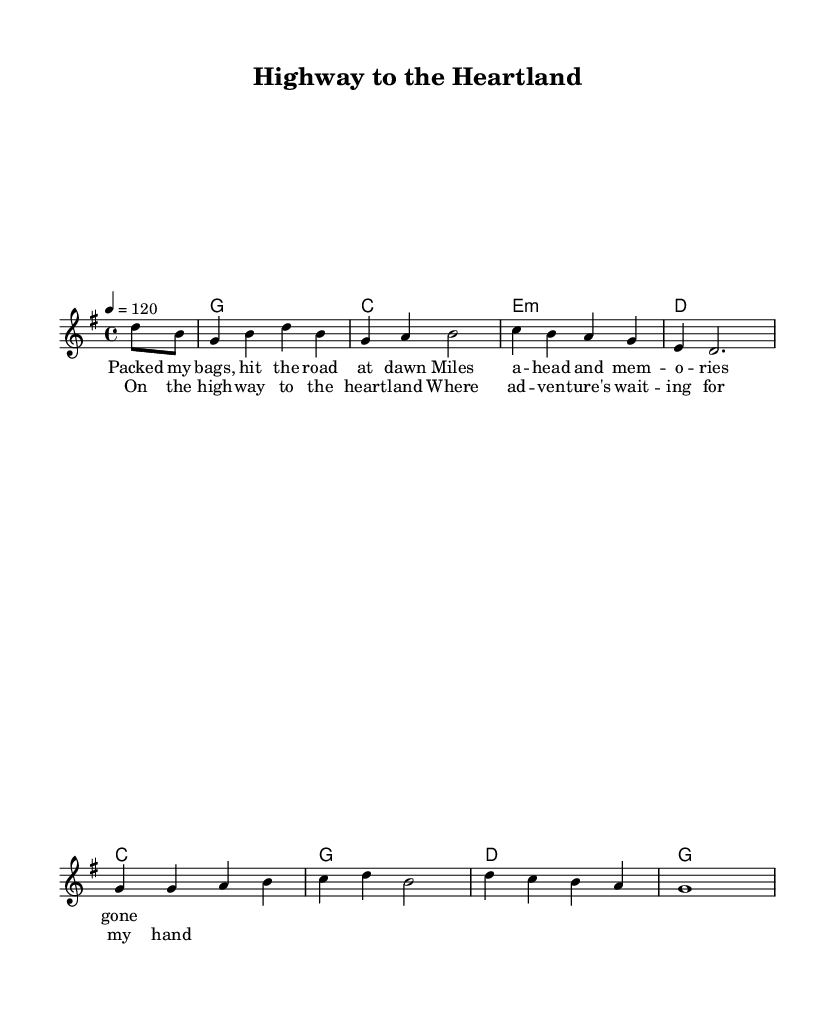What is the key signature of this music? The key signature is G major, which has one sharp (F#). This can be determined by identifying the key signature notation in the sheet music.
Answer: G major What is the time signature of this music? The time signature is 4/4, which means there are four beats in each measure and the quarter note gets one beat. This is indicated at the beginning of the score right after the key signature.
Answer: 4/4 What is the tempo marking for this piece? The tempo marking is 120 beats per minute, which is indicated with "4 = 120" in the tempo instructions. This designation tells the performer how fast to play the piece.
Answer: 120 beats per minute What is the main theme of the lyrics in this piece? The main theme of the lyrics revolves around travel and adventure, as reflected in lines like "Packed my bags, hit the road at dawn". The overall message conveys the excitement of heading towards new experiences.
Answer: Travel and adventure How many measures are there in the melody? The melody consists of eight measures. This can be counted by examining the structure of the melody line provided in the sheet music, where each group of notes is grouped into measures.
Answer: Eight measures What type of harmony is predominantly used in this piece? The harmony predominantly uses simple triadic chords, which are basic chords built on the first, third, and fifth notes of the scale. This can be seen clearly in the chord mode section of the sheet music.
Answer: Triadic chords What is the title of this music? The title provided in the header of the sheet music is "Highway to the Heartland". It is stated at the top of the sheet before any musical notation begins.
Answer: Highway to the Heartland 